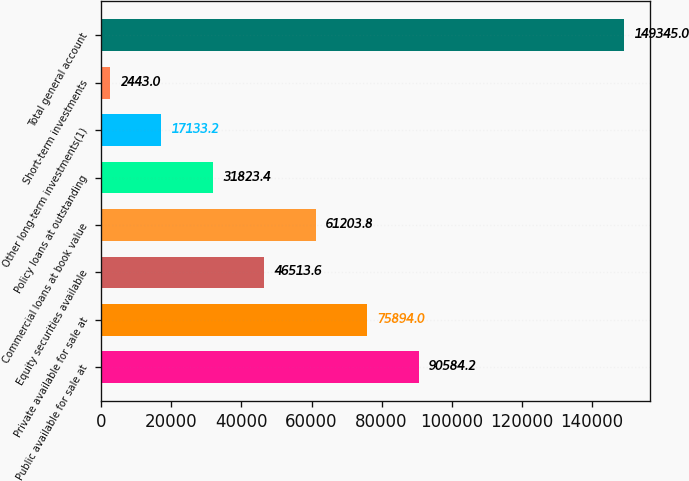Convert chart. <chart><loc_0><loc_0><loc_500><loc_500><bar_chart><fcel>Public available for sale at<fcel>Private available for sale at<fcel>Equity securities available<fcel>Commercial loans at book value<fcel>Policy loans at outstanding<fcel>Other long-term investments(1)<fcel>Short-term investments<fcel>Total general account<nl><fcel>90584.2<fcel>75894<fcel>46513.6<fcel>61203.8<fcel>31823.4<fcel>17133.2<fcel>2443<fcel>149345<nl></chart> 